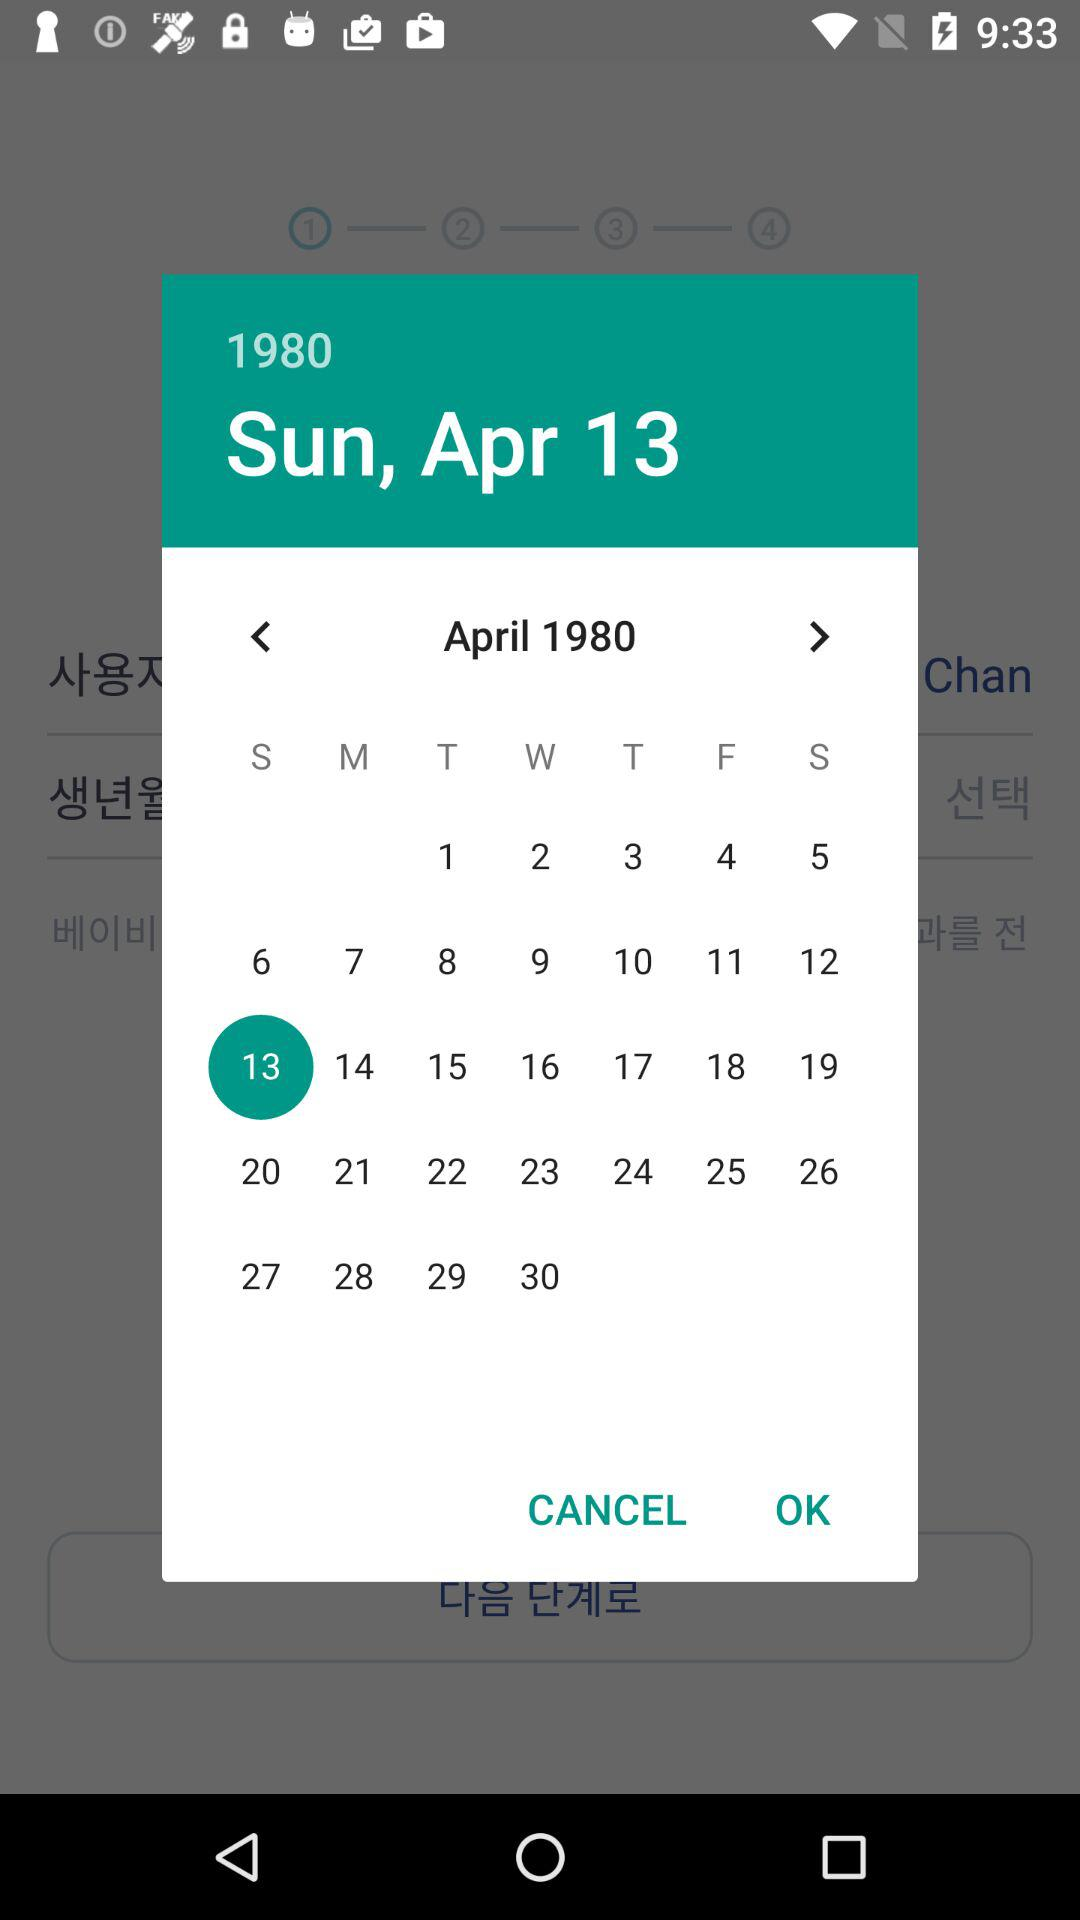Which date is selected? The selected date is Sunday, April 13, 1980. 